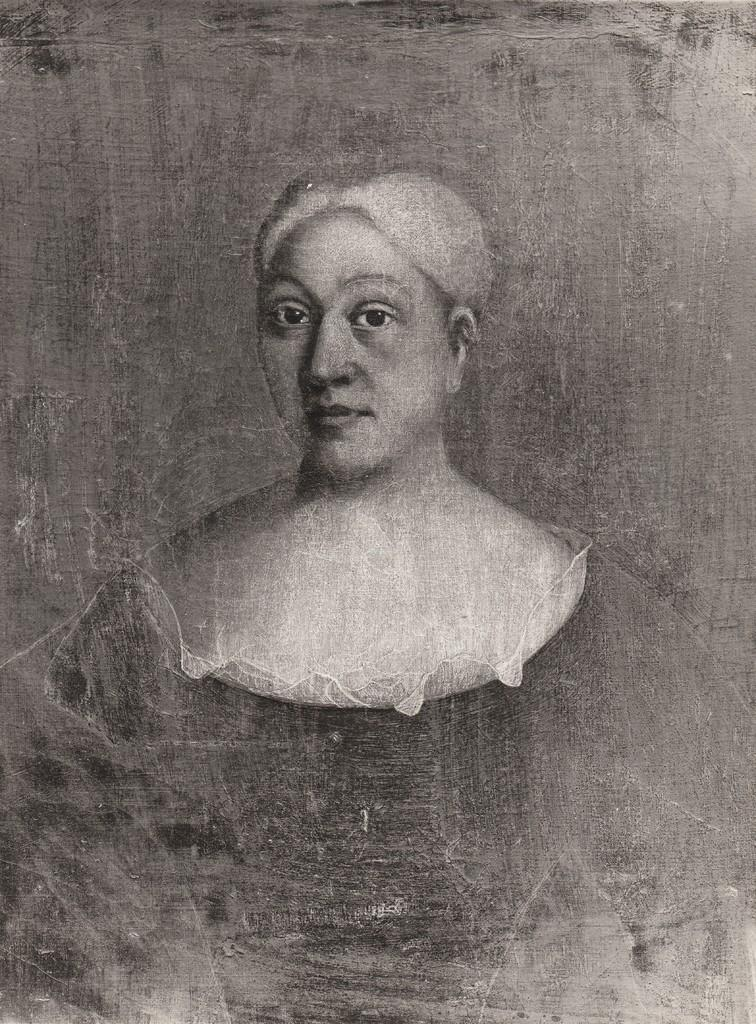What is the main subject of the image? The image contains a painting. What is depicted in the painting? The painting depicts a woman. What date is circled on the calendar in the image? There is no calendar present in the image. What type of appliance is visible in the image? There is no appliance visible in the image. 